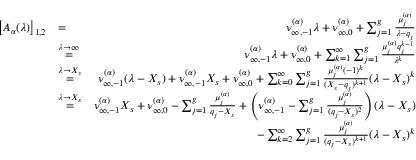<formula> <loc_0><loc_0><loc_500><loc_500>\begin{array} { r l r } { \left [ A _ { \alpha } ( \lambda ) \right ] _ { 1 , 2 } } & { = } & { \nu _ { \infty , - 1 } ^ { ( \alpha ) } \lambda + \nu _ { \infty , 0 } ^ { ( \alpha ) } + \sum _ { j = 1 } ^ { g } \frac { \mu _ { j } ^ { ( \alpha ) } } { \lambda - q _ { j } } } \\ & { \overset { \lambda \to \infty } { = } } & { \nu _ { \infty , - 1 } ^ { ( \alpha ) } \lambda + \nu _ { \infty , 0 } ^ { ( \alpha ) } + \sum _ { k = 1 } ^ { \infty } \sum _ { j = 1 } ^ { g } \frac { \mu _ { j } ^ { ( \alpha ) } q _ { j } ^ { k - 1 } } { \lambda ^ { k } } } \\ & { \overset { \lambda \to X _ { s } } { = } } & { \nu _ { \infty , - 1 } ^ { ( \alpha ) } ( \lambda - X _ { s } ) + \nu _ { \infty , - 1 } ^ { ( \alpha ) } X _ { s } + \nu _ { \infty , 0 } ^ { ( \alpha ) } + \sum _ { k = 0 } ^ { \infty } \sum _ { j = 1 } ^ { g } \frac { \mu _ { j } ^ { ( \alpha ) } ( - 1 ) ^ { k } } { ( X _ { s } - q _ { j } ) ^ { k + 1 } } ( \lambda - X _ { s } ) ^ { k } } \\ & { \overset { \lambda \to X _ { s } } { = } } & { \nu _ { \infty , - 1 } ^ { ( \alpha ) } X _ { s } + \nu _ { \infty , 0 } ^ { ( \alpha ) } - \sum _ { j = 1 } ^ { g } \frac { \mu _ { j } ^ { ( \alpha ) } } { q _ { j } - X _ { s } } + \left ( \nu _ { \infty , - 1 } ^ { ( \alpha ) } - \sum _ { j = 1 } ^ { g } \frac { \mu _ { j } ^ { ( \alpha ) } } { ( q _ { j } - X _ { s } ) ^ { 2 } } \right ) ( \lambda - X _ { s } ) } \\ & { - \sum _ { k = 2 } ^ { \infty } \sum _ { j = 1 } ^ { g } \frac { \mu _ { j } ^ { ( \alpha ) } } { ( q _ { j } - X _ { s } ) ^ { k + 1 } } ( \lambda - X _ { s } ) ^ { k } } \end{array}</formula> 